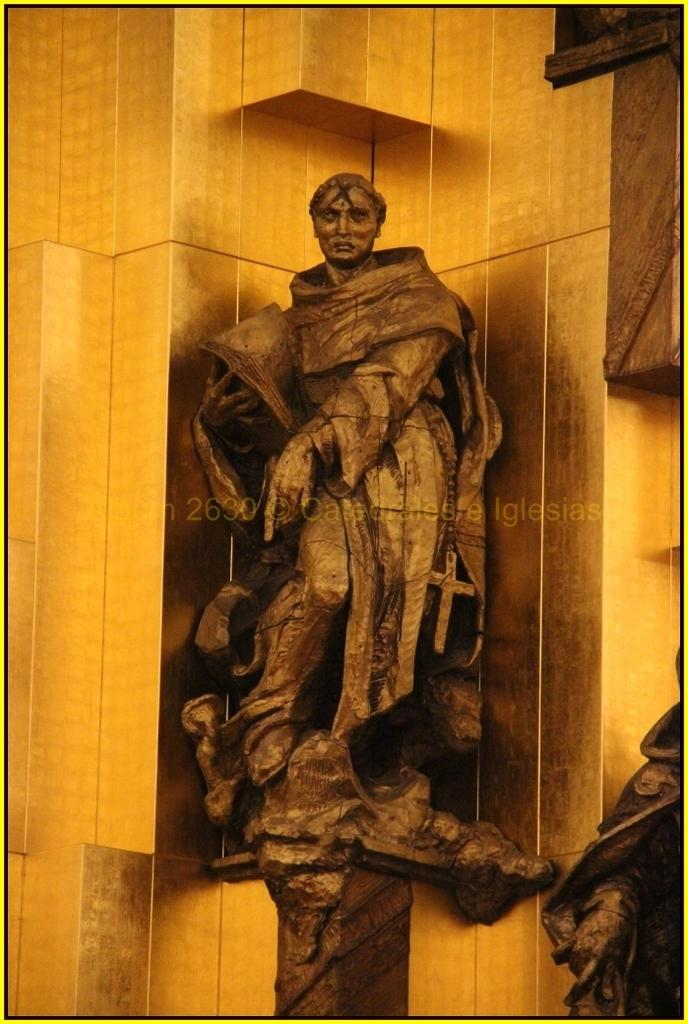How many sculptures are present in the image? There are two sculptures in the image. Can you describe the positioning of the first sculpture? The first sculpture is attached to the wall. What can be said about the second sculpture in the image? Unfortunately, the provided facts do not give any information about the second sculpture. What color is the wrist of the person holding the sculpture in the image? There is no person holding a sculpture in the image, and therefore no wrist to describe. 